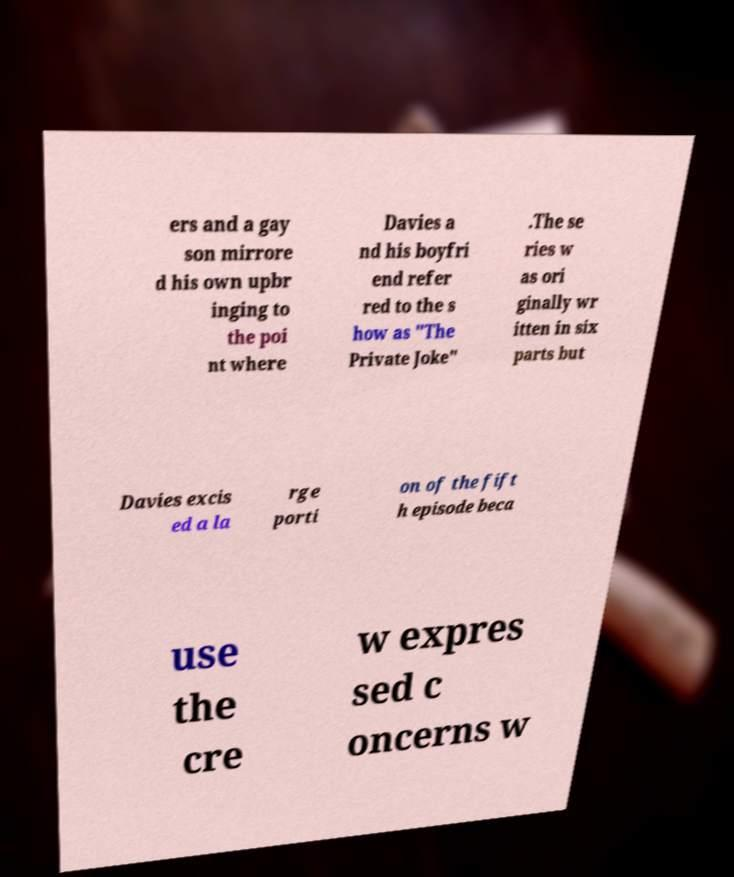There's text embedded in this image that I need extracted. Can you transcribe it verbatim? ers and a gay son mirrore d his own upbr inging to the poi nt where Davies a nd his boyfri end refer red to the s how as "The Private Joke" .The se ries w as ori ginally wr itten in six parts but Davies excis ed a la rge porti on of the fift h episode beca use the cre w expres sed c oncerns w 